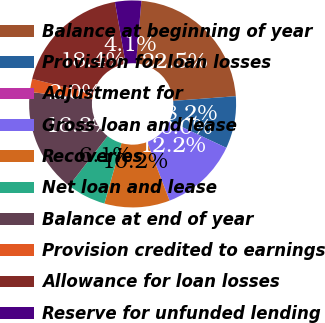Convert chart to OTSL. <chart><loc_0><loc_0><loc_500><loc_500><pie_chart><fcel>Balance at beginning of year<fcel>Provision for loan losses<fcel>Adjustment for<fcel>Gross loan and lease<fcel>Recoveries<fcel>Net loan and lease<fcel>Balance at end of year<fcel>Provision credited to earnings<fcel>Allowance for loan losses<fcel>Reserve for unfunded lending<nl><fcel>22.46%<fcel>8.16%<fcel>0.0%<fcel>12.23%<fcel>10.2%<fcel>6.12%<fcel>16.34%<fcel>2.04%<fcel>18.38%<fcel>4.08%<nl></chart> 